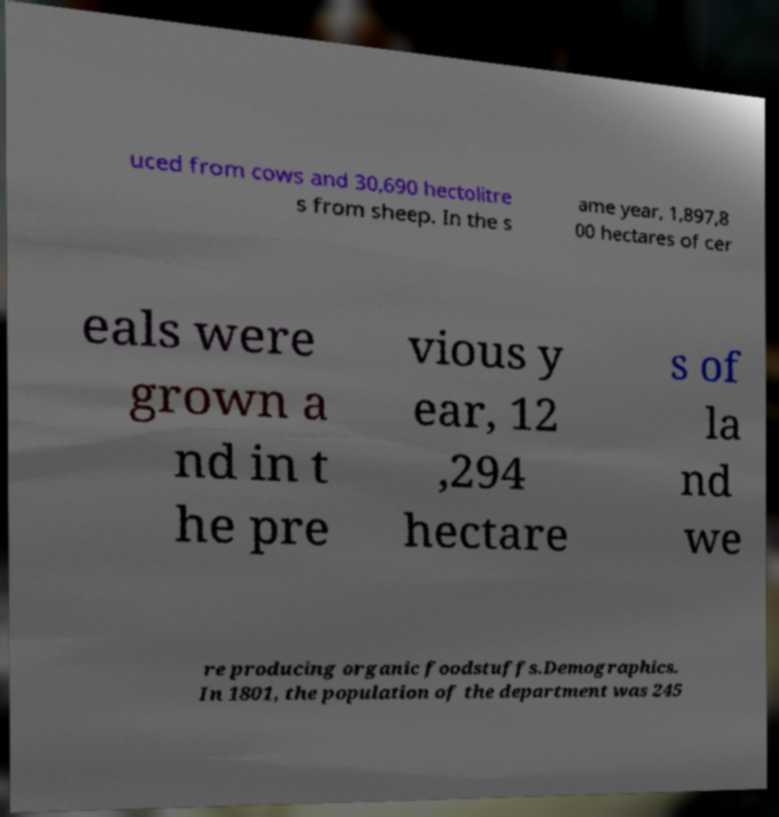There's text embedded in this image that I need extracted. Can you transcribe it verbatim? uced from cows and 30,690 hectolitre s from sheep. In the s ame year, 1,897,8 00 hectares of cer eals were grown a nd in t he pre vious y ear, 12 ,294 hectare s of la nd we re producing organic foodstuffs.Demographics. In 1801, the population of the department was 245 